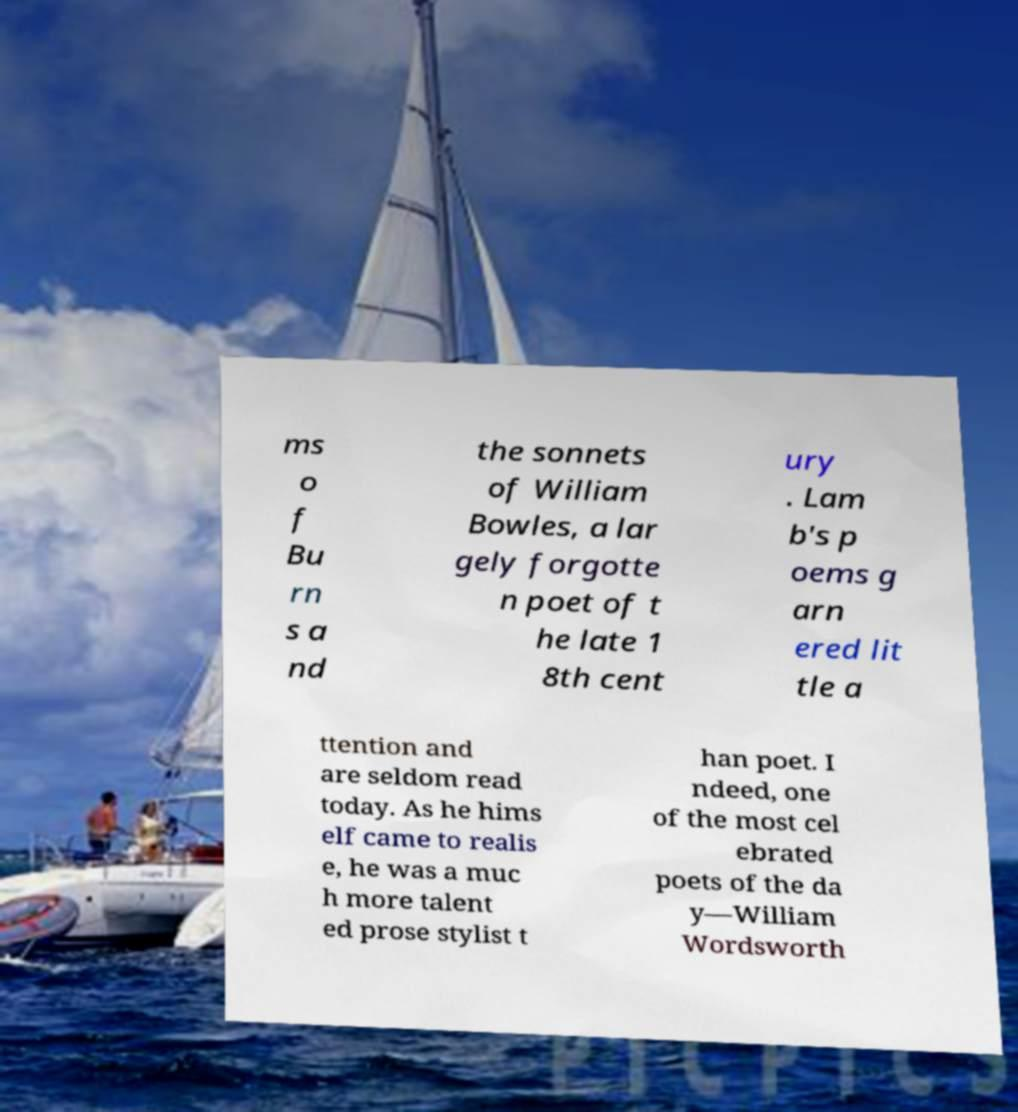There's text embedded in this image that I need extracted. Can you transcribe it verbatim? ms o f Bu rn s a nd the sonnets of William Bowles, a lar gely forgotte n poet of t he late 1 8th cent ury . Lam b's p oems g arn ered lit tle a ttention and are seldom read today. As he hims elf came to realis e, he was a muc h more talent ed prose stylist t han poet. I ndeed, one of the most cel ebrated poets of the da y—William Wordsworth 